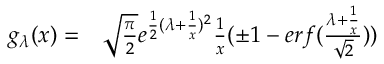<formula> <loc_0><loc_0><loc_500><loc_500>\begin{array} { r l } { g _ { \lambda } ( x ) = } & \sqrt { \frac { \pi } { 2 } } e ^ { \frac { 1 } { 2 } ( \lambda + \frac { 1 } { x } ) ^ { 2 } } \frac { 1 } { x } ( \pm 1 - e r f ( \frac { \lambda + \frac { 1 } { x } } { \sqrt { 2 } } ) ) } \end{array}</formula> 